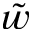<formula> <loc_0><loc_0><loc_500><loc_500>\tilde { w }</formula> 